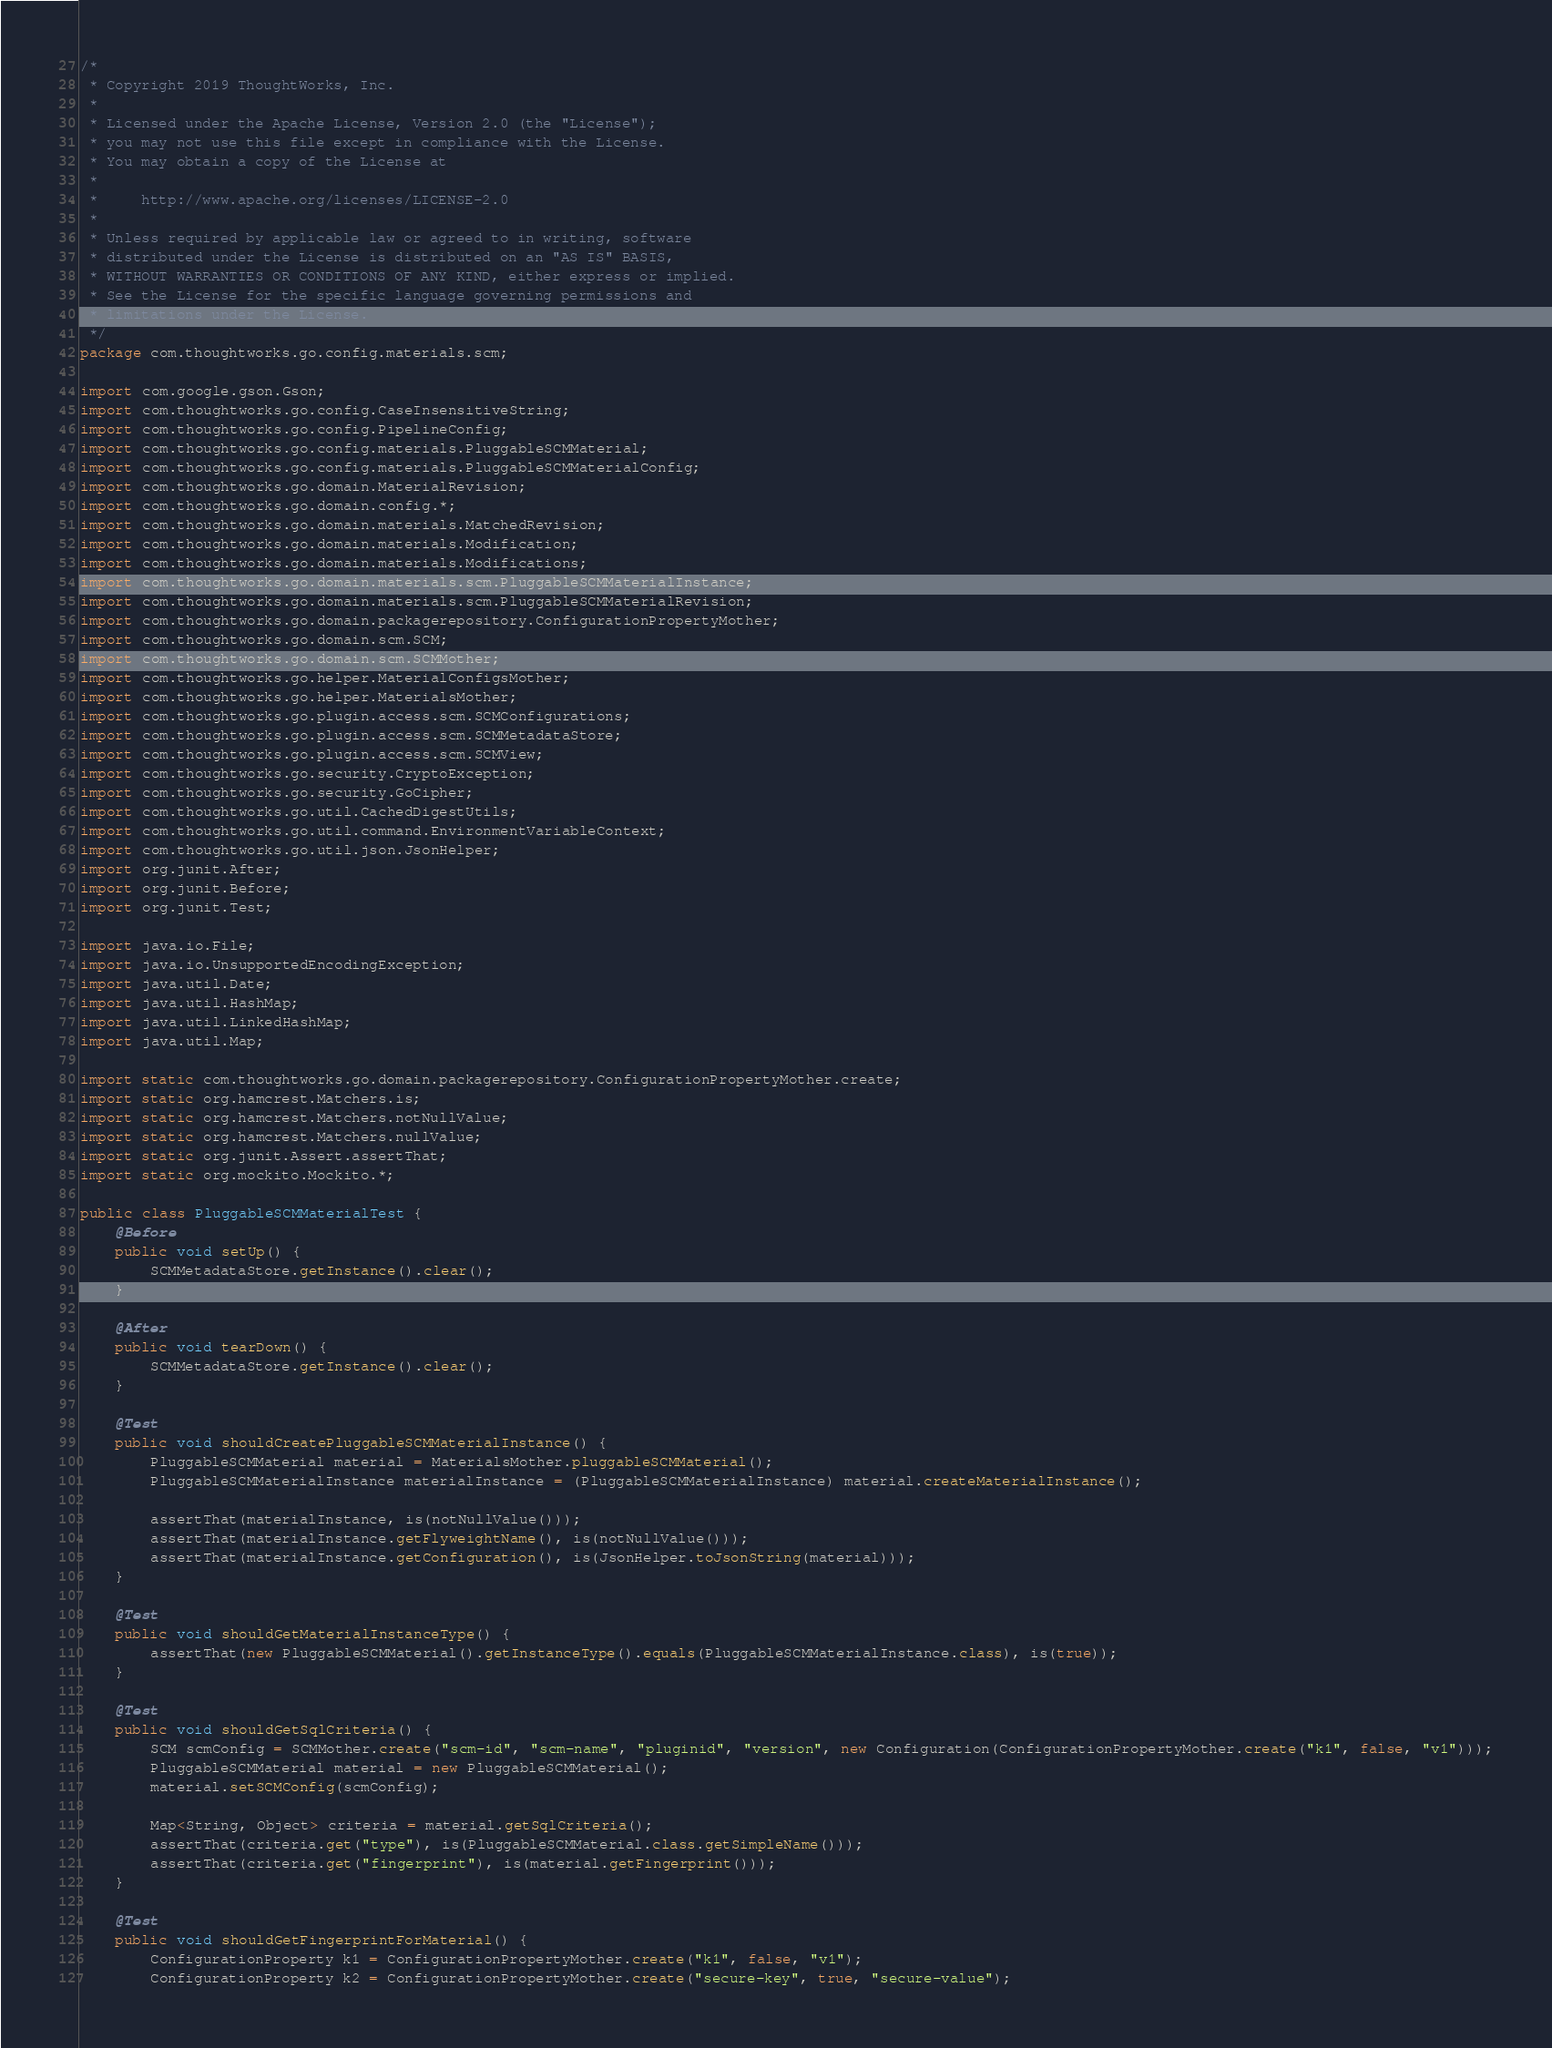Convert code to text. <code><loc_0><loc_0><loc_500><loc_500><_Java_>/*
 * Copyright 2019 ThoughtWorks, Inc.
 *
 * Licensed under the Apache License, Version 2.0 (the "License");
 * you may not use this file except in compliance with the License.
 * You may obtain a copy of the License at
 *
 *     http://www.apache.org/licenses/LICENSE-2.0
 *
 * Unless required by applicable law or agreed to in writing, software
 * distributed under the License is distributed on an "AS IS" BASIS,
 * WITHOUT WARRANTIES OR CONDITIONS OF ANY KIND, either express or implied.
 * See the License for the specific language governing permissions and
 * limitations under the License.
 */
package com.thoughtworks.go.config.materials.scm;

import com.google.gson.Gson;
import com.thoughtworks.go.config.CaseInsensitiveString;
import com.thoughtworks.go.config.PipelineConfig;
import com.thoughtworks.go.config.materials.PluggableSCMMaterial;
import com.thoughtworks.go.config.materials.PluggableSCMMaterialConfig;
import com.thoughtworks.go.domain.MaterialRevision;
import com.thoughtworks.go.domain.config.*;
import com.thoughtworks.go.domain.materials.MatchedRevision;
import com.thoughtworks.go.domain.materials.Modification;
import com.thoughtworks.go.domain.materials.Modifications;
import com.thoughtworks.go.domain.materials.scm.PluggableSCMMaterialInstance;
import com.thoughtworks.go.domain.materials.scm.PluggableSCMMaterialRevision;
import com.thoughtworks.go.domain.packagerepository.ConfigurationPropertyMother;
import com.thoughtworks.go.domain.scm.SCM;
import com.thoughtworks.go.domain.scm.SCMMother;
import com.thoughtworks.go.helper.MaterialConfigsMother;
import com.thoughtworks.go.helper.MaterialsMother;
import com.thoughtworks.go.plugin.access.scm.SCMConfigurations;
import com.thoughtworks.go.plugin.access.scm.SCMMetadataStore;
import com.thoughtworks.go.plugin.access.scm.SCMView;
import com.thoughtworks.go.security.CryptoException;
import com.thoughtworks.go.security.GoCipher;
import com.thoughtworks.go.util.CachedDigestUtils;
import com.thoughtworks.go.util.command.EnvironmentVariableContext;
import com.thoughtworks.go.util.json.JsonHelper;
import org.junit.After;
import org.junit.Before;
import org.junit.Test;

import java.io.File;
import java.io.UnsupportedEncodingException;
import java.util.Date;
import java.util.HashMap;
import java.util.LinkedHashMap;
import java.util.Map;

import static com.thoughtworks.go.domain.packagerepository.ConfigurationPropertyMother.create;
import static org.hamcrest.Matchers.is;
import static org.hamcrest.Matchers.notNullValue;
import static org.hamcrest.Matchers.nullValue;
import static org.junit.Assert.assertThat;
import static org.mockito.Mockito.*;

public class PluggableSCMMaterialTest {
    @Before
    public void setUp() {
        SCMMetadataStore.getInstance().clear();
    }

    @After
    public void tearDown() {
        SCMMetadataStore.getInstance().clear();
    }

    @Test
    public void shouldCreatePluggableSCMMaterialInstance() {
        PluggableSCMMaterial material = MaterialsMother.pluggableSCMMaterial();
        PluggableSCMMaterialInstance materialInstance = (PluggableSCMMaterialInstance) material.createMaterialInstance();

        assertThat(materialInstance, is(notNullValue()));
        assertThat(materialInstance.getFlyweightName(), is(notNullValue()));
        assertThat(materialInstance.getConfiguration(), is(JsonHelper.toJsonString(material)));
    }

    @Test
    public void shouldGetMaterialInstanceType() {
        assertThat(new PluggableSCMMaterial().getInstanceType().equals(PluggableSCMMaterialInstance.class), is(true));
    }

    @Test
    public void shouldGetSqlCriteria() {
        SCM scmConfig = SCMMother.create("scm-id", "scm-name", "pluginid", "version", new Configuration(ConfigurationPropertyMother.create("k1", false, "v1")));
        PluggableSCMMaterial material = new PluggableSCMMaterial();
        material.setSCMConfig(scmConfig);

        Map<String, Object> criteria = material.getSqlCriteria();
        assertThat(criteria.get("type"), is(PluggableSCMMaterial.class.getSimpleName()));
        assertThat(criteria.get("fingerprint"), is(material.getFingerprint()));
    }

    @Test
    public void shouldGetFingerprintForMaterial() {
        ConfigurationProperty k1 = ConfigurationPropertyMother.create("k1", false, "v1");
        ConfigurationProperty k2 = ConfigurationPropertyMother.create("secure-key", true, "secure-value");</code> 